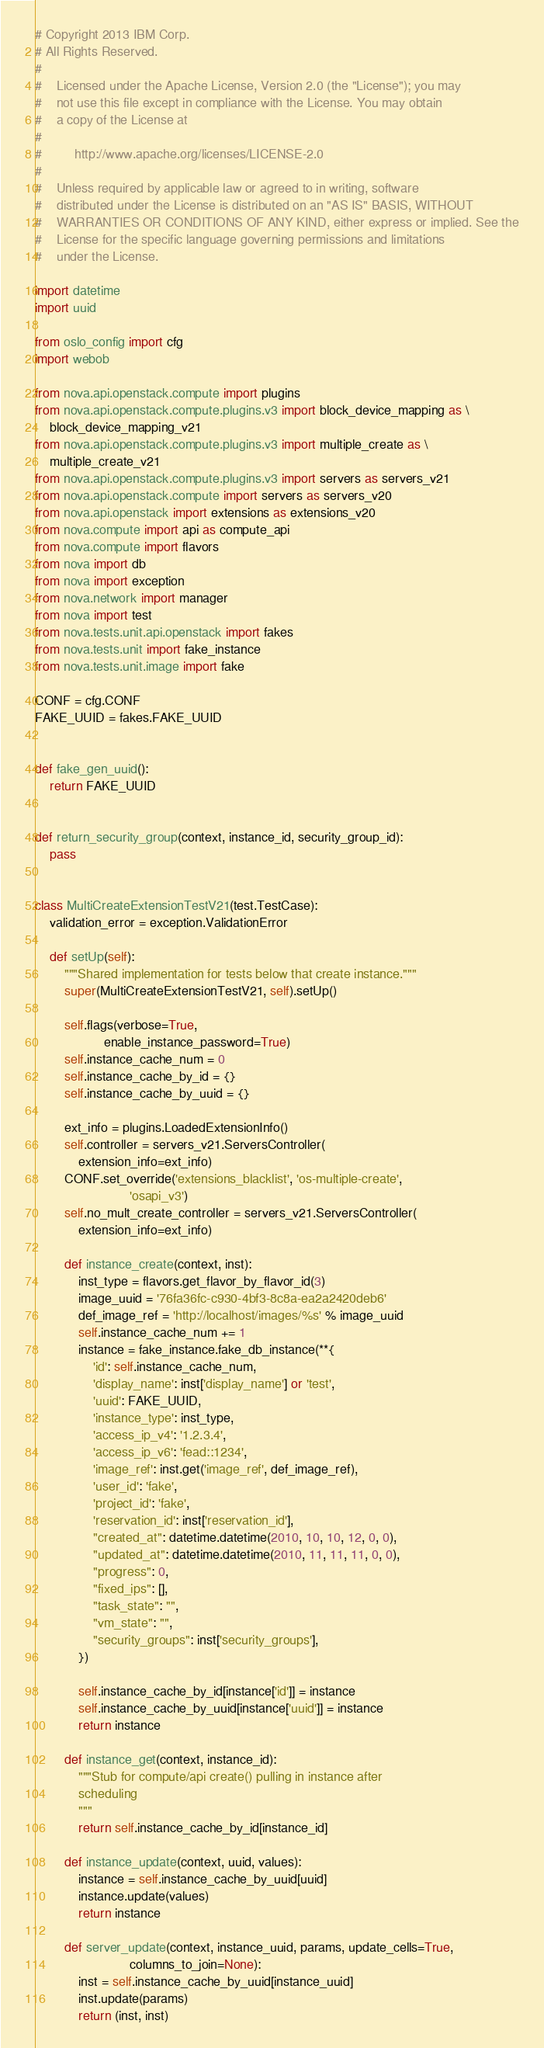<code> <loc_0><loc_0><loc_500><loc_500><_Python_># Copyright 2013 IBM Corp.
# All Rights Reserved.
#
#    Licensed under the Apache License, Version 2.0 (the "License"); you may
#    not use this file except in compliance with the License. You may obtain
#    a copy of the License at
#
#         http://www.apache.org/licenses/LICENSE-2.0
#
#    Unless required by applicable law or agreed to in writing, software
#    distributed under the License is distributed on an "AS IS" BASIS, WITHOUT
#    WARRANTIES OR CONDITIONS OF ANY KIND, either express or implied. See the
#    License for the specific language governing permissions and limitations
#    under the License.

import datetime
import uuid

from oslo_config import cfg
import webob

from nova.api.openstack.compute import plugins
from nova.api.openstack.compute.plugins.v3 import block_device_mapping as \
    block_device_mapping_v21
from nova.api.openstack.compute.plugins.v3 import multiple_create as \
    multiple_create_v21
from nova.api.openstack.compute.plugins.v3 import servers as servers_v21
from nova.api.openstack.compute import servers as servers_v20
from nova.api.openstack import extensions as extensions_v20
from nova.compute import api as compute_api
from nova.compute import flavors
from nova import db
from nova import exception
from nova.network import manager
from nova import test
from nova.tests.unit.api.openstack import fakes
from nova.tests.unit import fake_instance
from nova.tests.unit.image import fake

CONF = cfg.CONF
FAKE_UUID = fakes.FAKE_UUID


def fake_gen_uuid():
    return FAKE_UUID


def return_security_group(context, instance_id, security_group_id):
    pass


class MultiCreateExtensionTestV21(test.TestCase):
    validation_error = exception.ValidationError

    def setUp(self):
        """Shared implementation for tests below that create instance."""
        super(MultiCreateExtensionTestV21, self).setUp()

        self.flags(verbose=True,
                   enable_instance_password=True)
        self.instance_cache_num = 0
        self.instance_cache_by_id = {}
        self.instance_cache_by_uuid = {}

        ext_info = plugins.LoadedExtensionInfo()
        self.controller = servers_v21.ServersController(
            extension_info=ext_info)
        CONF.set_override('extensions_blacklist', 'os-multiple-create',
                          'osapi_v3')
        self.no_mult_create_controller = servers_v21.ServersController(
            extension_info=ext_info)

        def instance_create(context, inst):
            inst_type = flavors.get_flavor_by_flavor_id(3)
            image_uuid = '76fa36fc-c930-4bf3-8c8a-ea2a2420deb6'
            def_image_ref = 'http://localhost/images/%s' % image_uuid
            self.instance_cache_num += 1
            instance = fake_instance.fake_db_instance(**{
                'id': self.instance_cache_num,
                'display_name': inst['display_name'] or 'test',
                'uuid': FAKE_UUID,
                'instance_type': inst_type,
                'access_ip_v4': '1.2.3.4',
                'access_ip_v6': 'fead::1234',
                'image_ref': inst.get('image_ref', def_image_ref),
                'user_id': 'fake',
                'project_id': 'fake',
                'reservation_id': inst['reservation_id'],
                "created_at": datetime.datetime(2010, 10, 10, 12, 0, 0),
                "updated_at": datetime.datetime(2010, 11, 11, 11, 0, 0),
                "progress": 0,
                "fixed_ips": [],
                "task_state": "",
                "vm_state": "",
                "security_groups": inst['security_groups'],
            })

            self.instance_cache_by_id[instance['id']] = instance
            self.instance_cache_by_uuid[instance['uuid']] = instance
            return instance

        def instance_get(context, instance_id):
            """Stub for compute/api create() pulling in instance after
            scheduling
            """
            return self.instance_cache_by_id[instance_id]

        def instance_update(context, uuid, values):
            instance = self.instance_cache_by_uuid[uuid]
            instance.update(values)
            return instance

        def server_update(context, instance_uuid, params, update_cells=True,
                          columns_to_join=None):
            inst = self.instance_cache_by_uuid[instance_uuid]
            inst.update(params)
            return (inst, inst)
</code> 